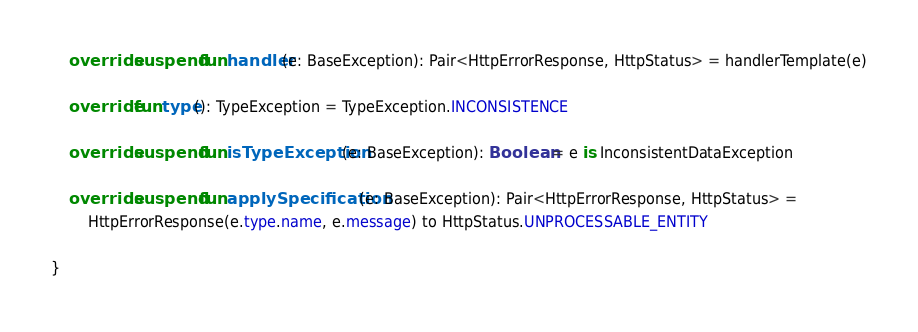Convert code to text. <code><loc_0><loc_0><loc_500><loc_500><_Kotlin_>
    override suspend fun handler(e: BaseException): Pair<HttpErrorResponse, HttpStatus> = handlerTemplate(e)

    override fun type(): TypeException = TypeException.INCONSISTENCE

    override suspend fun isTypeException(e: BaseException): Boolean = e is InconsistentDataException

    override suspend fun applySpecification(e: BaseException): Pair<HttpErrorResponse, HttpStatus> =
        HttpErrorResponse(e.type.name, e.message) to HttpStatus.UNPROCESSABLE_ENTITY

}</code> 